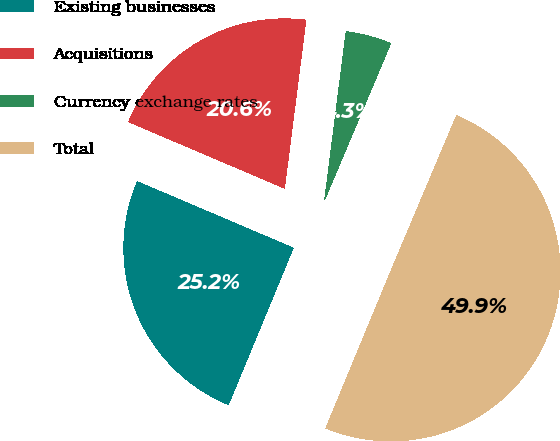<chart> <loc_0><loc_0><loc_500><loc_500><pie_chart><fcel>Existing businesses<fcel>Acquisitions<fcel>Currency exchange rates<fcel>Total<nl><fcel>25.16%<fcel>20.61%<fcel>4.34%<fcel>49.89%<nl></chart> 